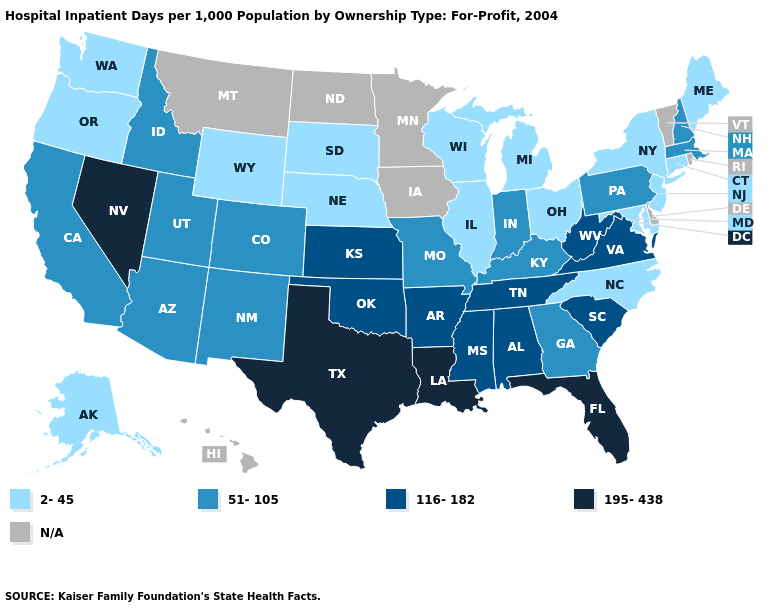What is the lowest value in the Northeast?
Answer briefly. 2-45. What is the value of Louisiana?
Quick response, please. 195-438. Which states have the lowest value in the Northeast?
Short answer required. Connecticut, Maine, New Jersey, New York. What is the lowest value in the Northeast?
Be succinct. 2-45. What is the highest value in the West ?
Short answer required. 195-438. How many symbols are there in the legend?
Answer briefly. 5. Which states have the highest value in the USA?
Short answer required. Florida, Louisiana, Nevada, Texas. What is the highest value in the Northeast ?
Write a very short answer. 51-105. What is the value of Washington?
Keep it brief. 2-45. Name the states that have a value in the range 51-105?
Concise answer only. Arizona, California, Colorado, Georgia, Idaho, Indiana, Kentucky, Massachusetts, Missouri, New Hampshire, New Mexico, Pennsylvania, Utah. Does Maryland have the lowest value in the South?
Quick response, please. Yes. Name the states that have a value in the range 195-438?
Write a very short answer. Florida, Louisiana, Nevada, Texas. What is the lowest value in the Northeast?
Quick response, please. 2-45. What is the value of Ohio?
Keep it brief. 2-45. 